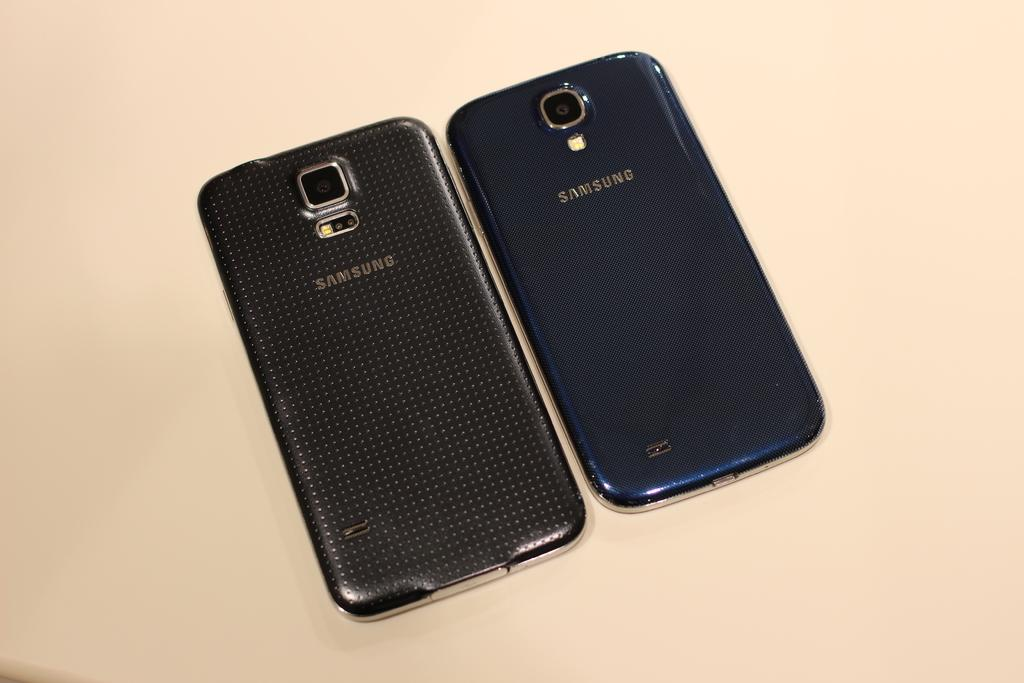<image>
Summarize the visual content of the image. two facedown samsung phones, one is dark blue and the other seems to be carbon fiber 